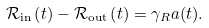Convert formula to latex. <formula><loc_0><loc_0><loc_500><loc_500>\mathcal { R } _ { \text {in} } \left ( t \right ) - \mathcal { R } _ { \text {out} } \left ( t \right ) = \gamma _ { R } a ( t ) .</formula> 